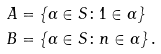Convert formula to latex. <formula><loc_0><loc_0><loc_500><loc_500>A & = \left \{ \alpha \in S \colon 1 \in \alpha \right \} \\ B & = \left \{ \alpha \in S \colon n \in \alpha \right \} .</formula> 